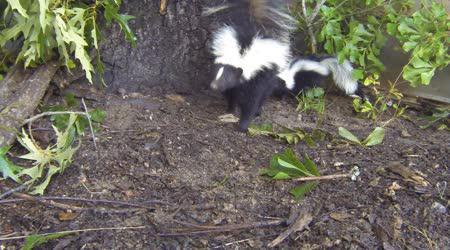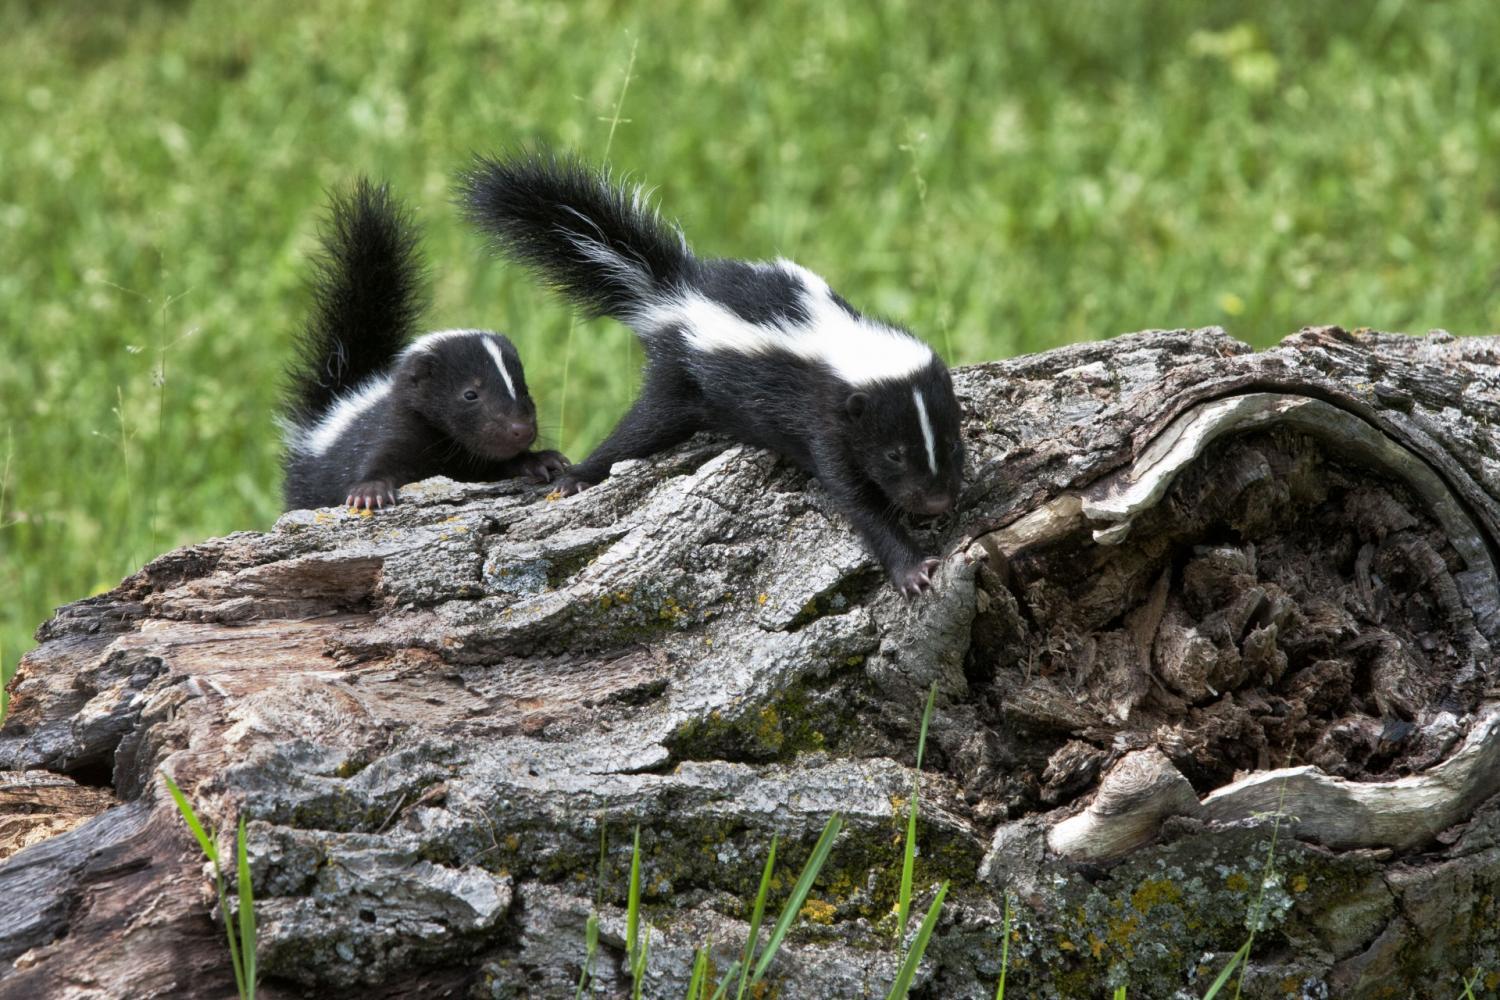The first image is the image on the left, the second image is the image on the right. Assess this claim about the two images: "Two skunks are on a piece of wood in one of the images.". Correct or not? Answer yes or no. Yes. The first image is the image on the left, the second image is the image on the right. For the images displayed, is the sentence "The right image shows at least two skunks by the hollow of a fallen log." factually correct? Answer yes or no. Yes. 